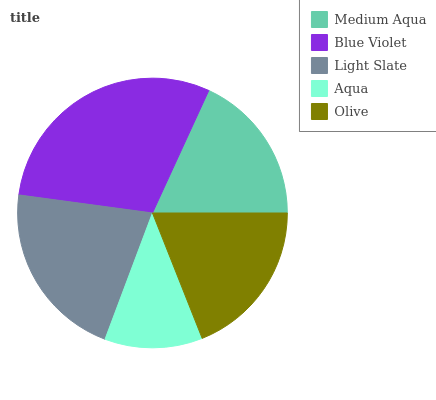Is Aqua the minimum?
Answer yes or no. Yes. Is Blue Violet the maximum?
Answer yes or no. Yes. Is Light Slate the minimum?
Answer yes or no. No. Is Light Slate the maximum?
Answer yes or no. No. Is Blue Violet greater than Light Slate?
Answer yes or no. Yes. Is Light Slate less than Blue Violet?
Answer yes or no. Yes. Is Light Slate greater than Blue Violet?
Answer yes or no. No. Is Blue Violet less than Light Slate?
Answer yes or no. No. Is Olive the high median?
Answer yes or no. Yes. Is Olive the low median?
Answer yes or no. Yes. Is Blue Violet the high median?
Answer yes or no. No. Is Aqua the low median?
Answer yes or no. No. 